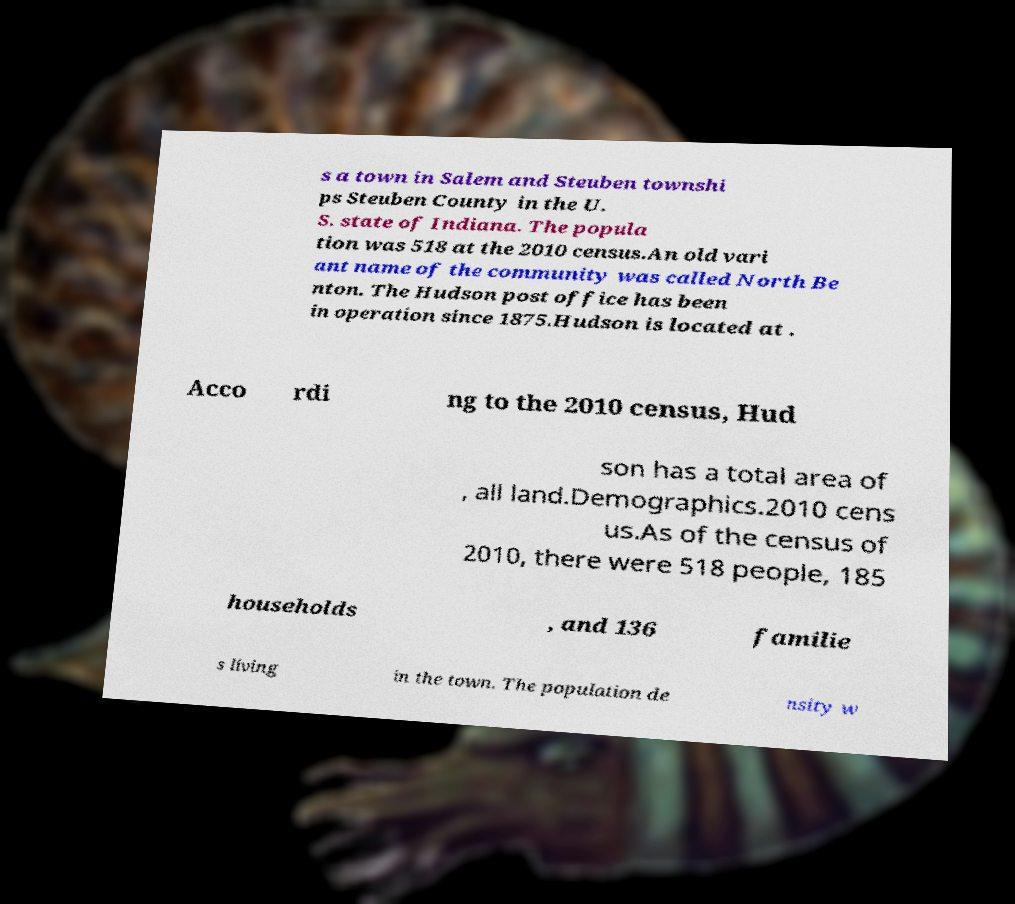Please identify and transcribe the text found in this image. s a town in Salem and Steuben townshi ps Steuben County in the U. S. state of Indiana. The popula tion was 518 at the 2010 census.An old vari ant name of the community was called North Be nton. The Hudson post office has been in operation since 1875.Hudson is located at . Acco rdi ng to the 2010 census, Hud son has a total area of , all land.Demographics.2010 cens us.As of the census of 2010, there were 518 people, 185 households , and 136 familie s living in the town. The population de nsity w 